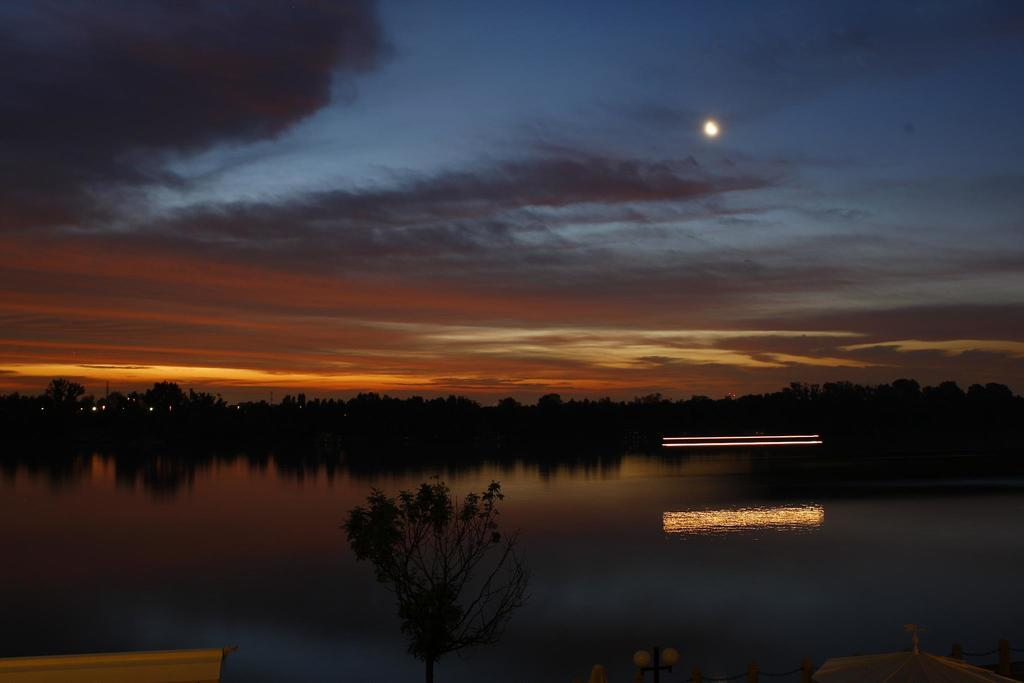What is the lighting condition in the image? The image is taken in the dark. What natural element can be seen in the image? There is water visible in the image. What type of vegetation is present in the image? There are trees in the image. What artificial light sources are visible in the image? There are lights in the image. What celestial body is visible in the background of the image? The moon is visible in the background of the image. What atmospheric conditions can be observed in the background of the image? There are clouds in the background of the image. What is the color of the sky in the image? The sky is dark in the image. What type of cream can be seen on the coast in the image? There is no cream or coast present in the image. How many pages are visible in the image? There are no pages present in the image. 